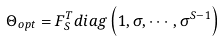Convert formula to latex. <formula><loc_0><loc_0><loc_500><loc_500>\Theta _ { o p t } = F _ { S } ^ { T } d i a g \left ( 1 , \sigma , \cdots , \sigma ^ { S - 1 } \right )</formula> 